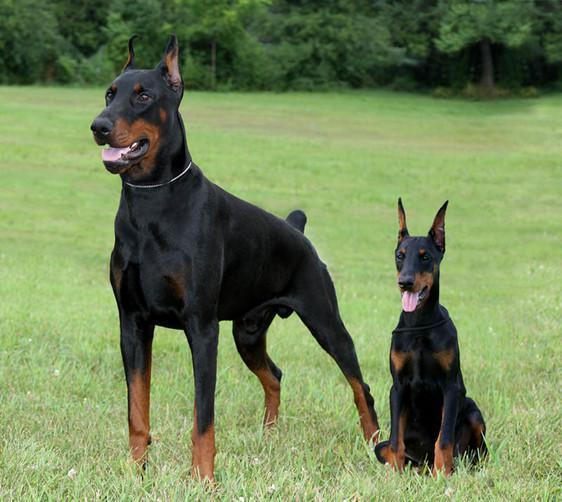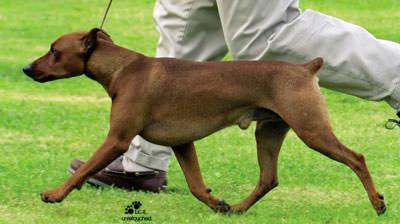The first image is the image on the left, the second image is the image on the right. For the images displayed, is the sentence "The right image contains no more than two dogs." factually correct? Answer yes or no. Yes. The first image is the image on the left, the second image is the image on the right. Assess this claim about the two images: "In the left image, two dogs are standing side-by-side, with their bodies and heads turned in the same direction.". Correct or not? Answer yes or no. No. 